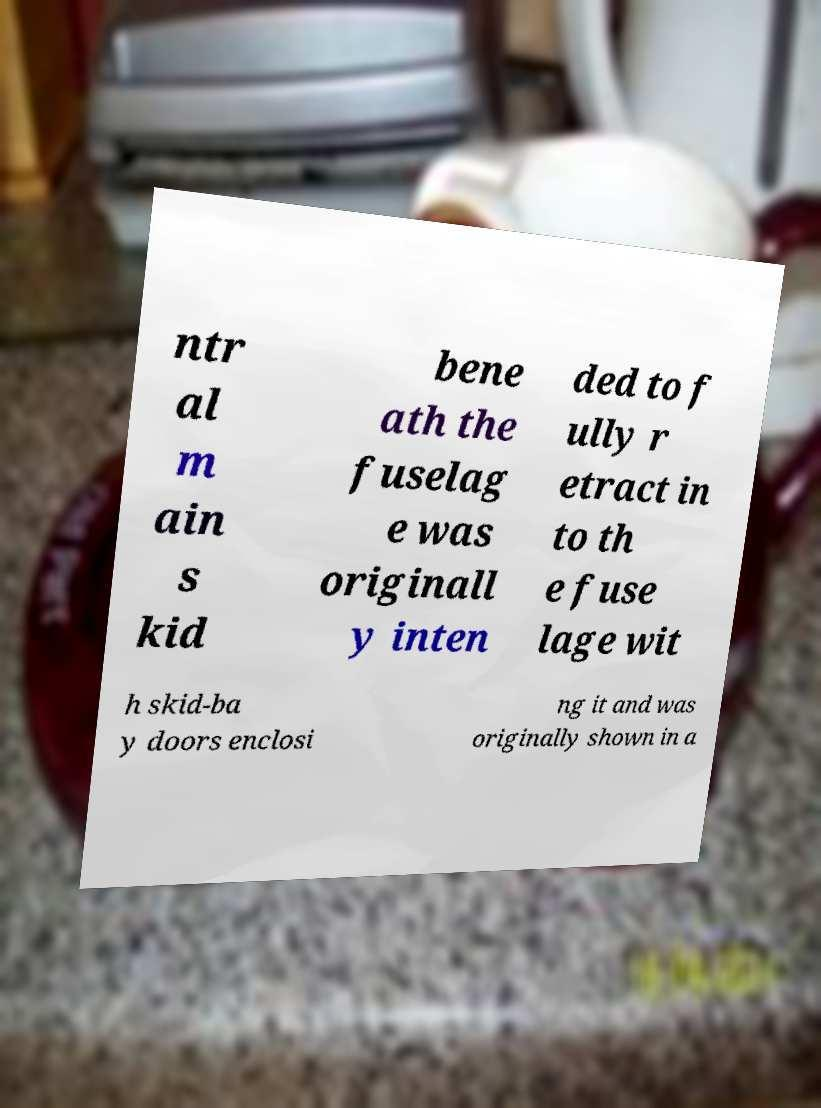There's text embedded in this image that I need extracted. Can you transcribe it verbatim? ntr al m ain s kid bene ath the fuselag e was originall y inten ded to f ully r etract in to th e fuse lage wit h skid-ba y doors enclosi ng it and was originally shown in a 